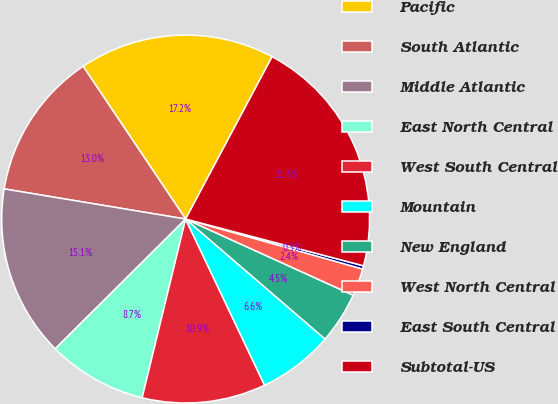<chart> <loc_0><loc_0><loc_500><loc_500><pie_chart><fcel>Pacific<fcel>South Atlantic<fcel>Middle Atlantic<fcel>East North Central<fcel>West South Central<fcel>Mountain<fcel>New England<fcel>West North Central<fcel>East South Central<fcel>Subtotal-US<nl><fcel>17.2%<fcel>12.97%<fcel>15.08%<fcel>8.74%<fcel>10.86%<fcel>6.63%<fcel>4.52%<fcel>2.41%<fcel>0.29%<fcel>21.3%<nl></chart> 